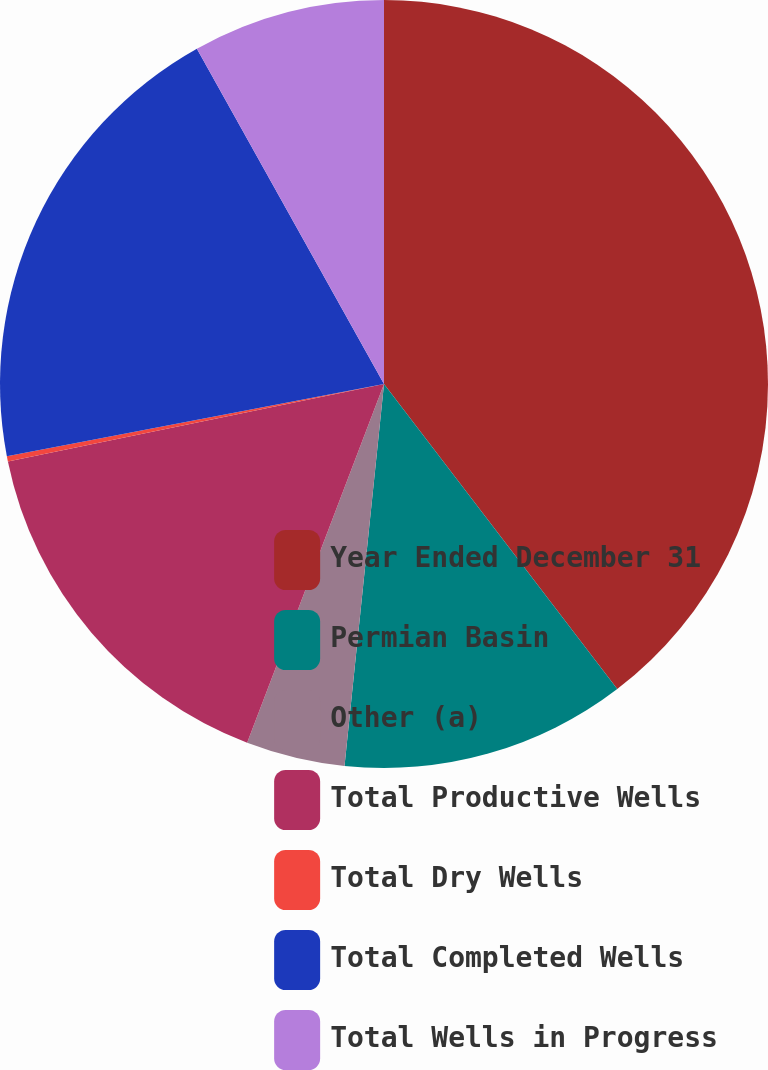<chart> <loc_0><loc_0><loc_500><loc_500><pie_chart><fcel>Year Ended December 31<fcel>Permian Basin<fcel>Other (a)<fcel>Total Productive Wells<fcel>Total Dry Wells<fcel>Total Completed Wells<fcel>Total Wells in Progress<nl><fcel>39.61%<fcel>12.03%<fcel>4.16%<fcel>15.97%<fcel>0.22%<fcel>19.91%<fcel>8.1%<nl></chart> 